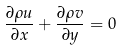Convert formula to latex. <formula><loc_0><loc_0><loc_500><loc_500>\frac { \partial \rho u } { \partial x } + \frac { \partial \rho v } { \partial y } = 0</formula> 